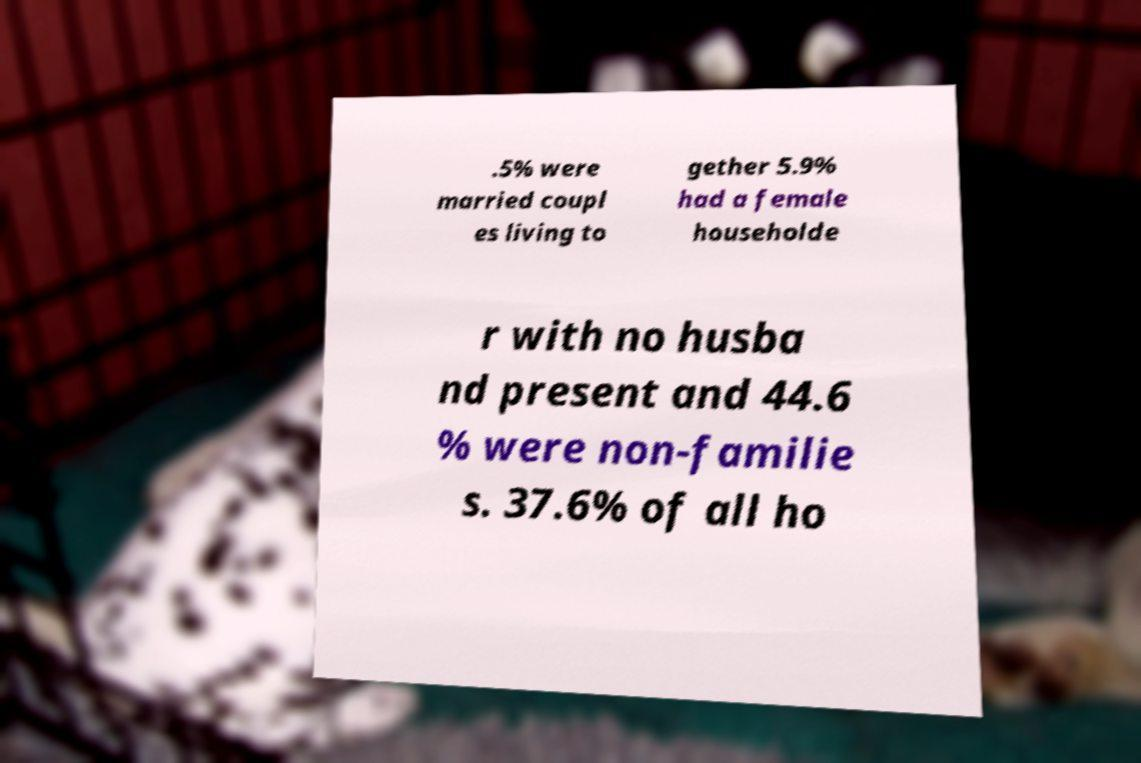Could you assist in decoding the text presented in this image and type it out clearly? .5% were married coupl es living to gether 5.9% had a female householde r with no husba nd present and 44.6 % were non-familie s. 37.6% of all ho 